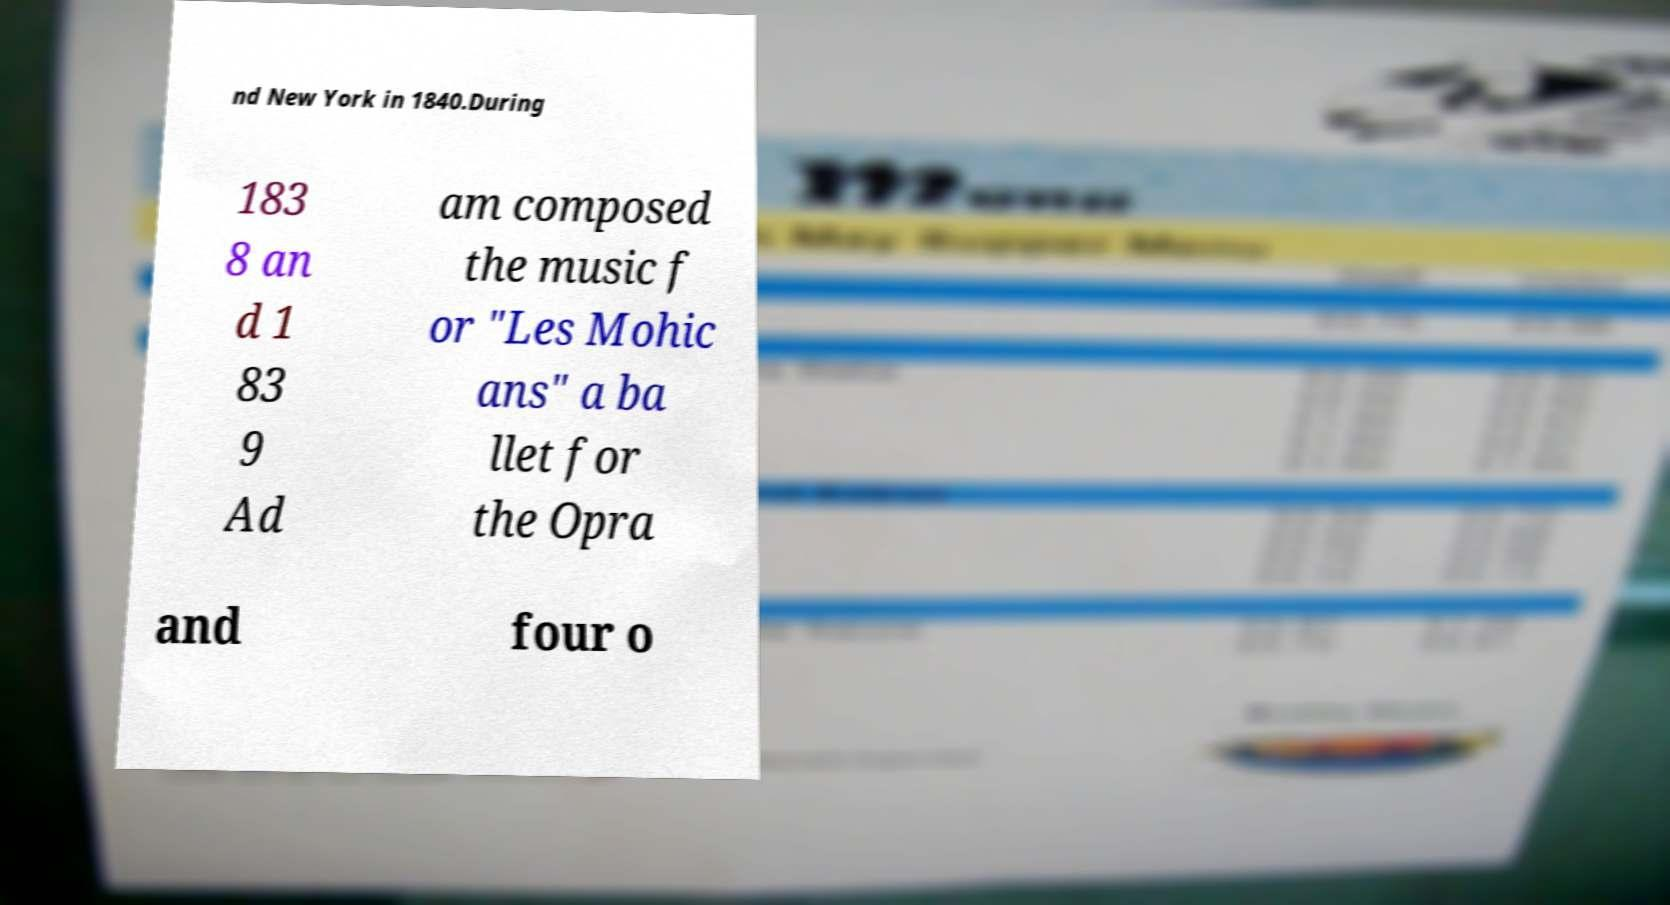I need the written content from this picture converted into text. Can you do that? nd New York in 1840.During 183 8 an d 1 83 9 Ad am composed the music f or "Les Mohic ans" a ba llet for the Opra and four o 